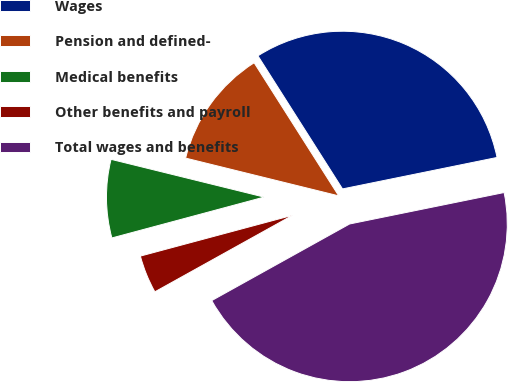<chart> <loc_0><loc_0><loc_500><loc_500><pie_chart><fcel>Wages<fcel>Pension and defined-<fcel>Medical benefits<fcel>Other benefits and payroll<fcel>Total wages and benefits<nl><fcel>30.81%<fcel>12.14%<fcel>8.02%<fcel>3.9%<fcel>45.12%<nl></chart> 